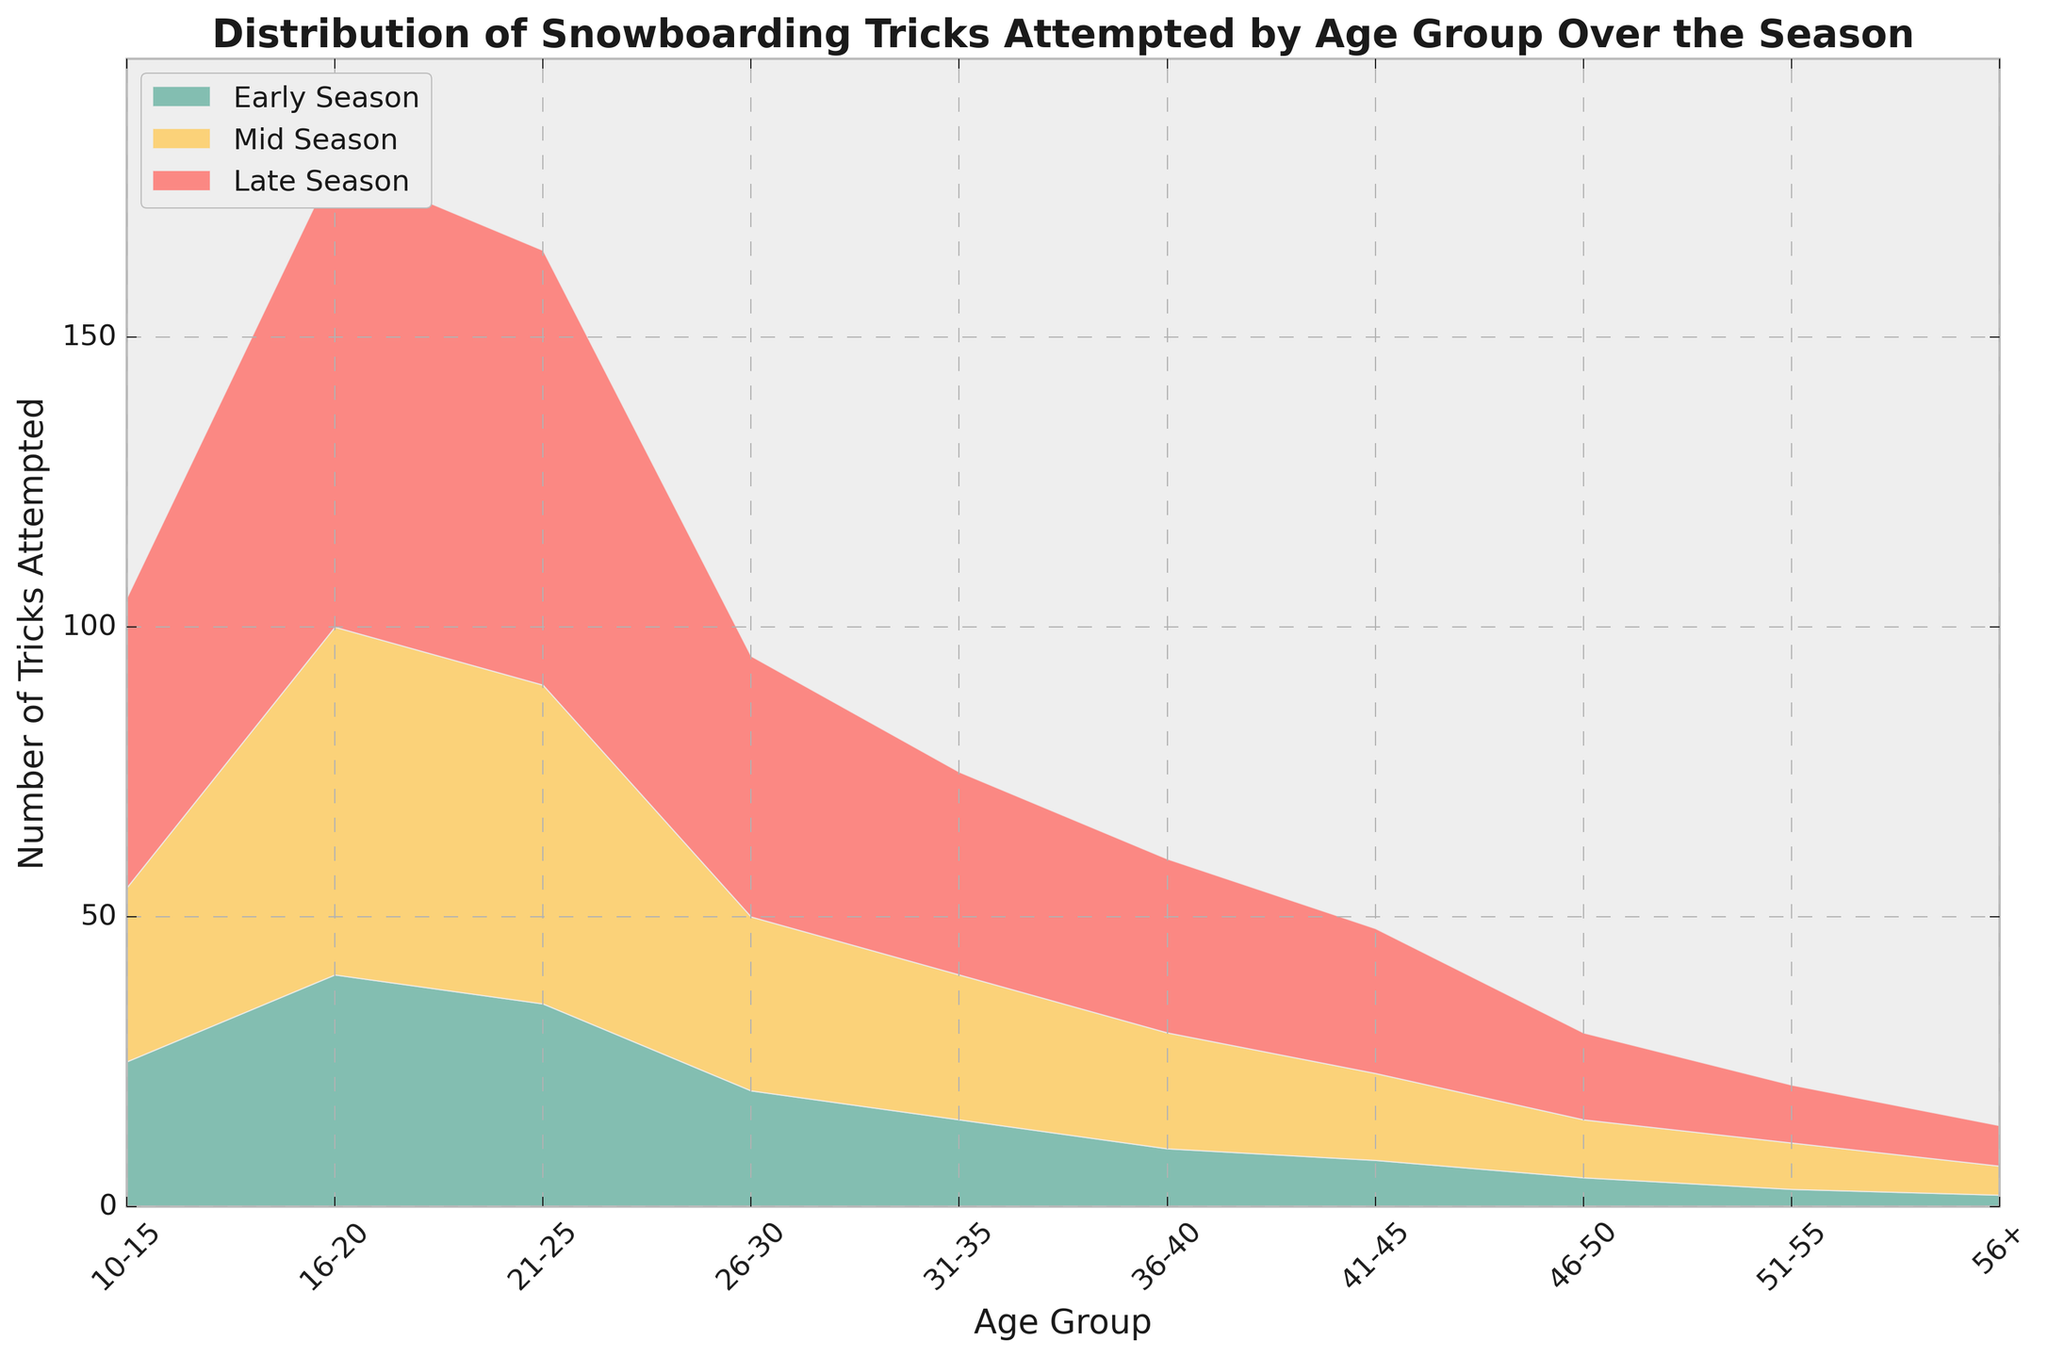What is the trend of snowboarding tricks attempted by the age group 16-20 over the season? The age group 16-20 shows an increasing trend over the season. At the Early Season, the number of tricks attempted is 40, at Mid Season, it increases to 60, and at Late Season, it further rises to 80
Answer: Increasing Which age group attempts the most snowboarding tricks by Late Season? By referring to the 'Late Season' data, the age group 16-20 attempts the most tricks, with a total of 80 tricks
Answer: 16-20 How does the number of tricks attempted by the age group 31-35 in Early Season compare to the age group 41-45 in Late Season? The age group 31-35 attempts 15 tricks in Early Season, while the age group 41-45 attempts 25 tricks in Late Season. Hence, 31-35 in Early Season is less than 41-45 in Late Season
Answer: 31-35 < 41-45 What is the combined number of tricks attempted by the age groups 10-15 and 56+ in Mid Season? The number of tricks attempted by 10-15 in Mid Season is 30, and by 56+ is 5. Adding these together, 30 + 5 = 35 tricks attempted in total
Answer: 35 Which season shows the largest increase in the number of tricks attempted for the age group 21-25? Comparing the increases, from Early Season to Mid Season is 20 (55 - 35), and from Mid Season to Late Season is also 20 (75 - 55). Both seasons show an equal increase
Answer: Early Season to Mid Season, Mid Season to Late Season What is the color associated with the Mid Season data in the area chart? The color representing Mid Season in the area chart is yellow
Answer: Yellow By how much does the number of tricks attempted by the age group 26-30 increase from Early Season to Late Season? For the age group 26-30, the number of tricks attempted increases from 20 in Early Season to 45 in Late Season. The increase is 45 - 20 = 25
Answer: 25 Is there any age group that consistently shows a decreasing trend over all seasons? All age groups show an increasing trend over all seasons, rather than a decreasing one
Answer: No How many tricks are attempted by the age group 36-40 in total across all seasons? The total for the age group 36-40 is calculated by summing the attempts over all seasons: 10 (Early) + 20 (Mid) + 30 (Late) = 60
Answer: 60 Which age group shows the smallest change in the number of tricks attempted from Early Season to Late Season? The smallest change is shown by the age group 56+, increasing from 2 in Early Season to 7 in Late Season. The change is 7 - 2 = 5
Answer: 56+ 